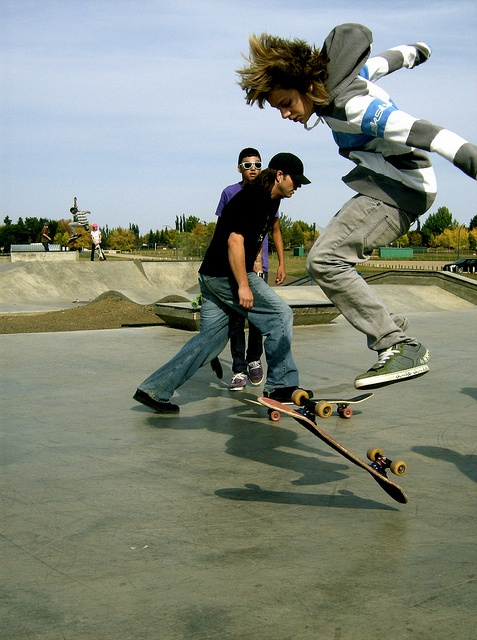Describe the objects in this image and their specific colors. I can see people in darkgray, black, gray, and white tones, people in darkgray, black, teal, and tan tones, skateboard in darkgray, black, olive, and gray tones, people in darkgray, black, navy, purple, and maroon tones, and skateboard in darkgray, black, tan, gray, and khaki tones in this image. 